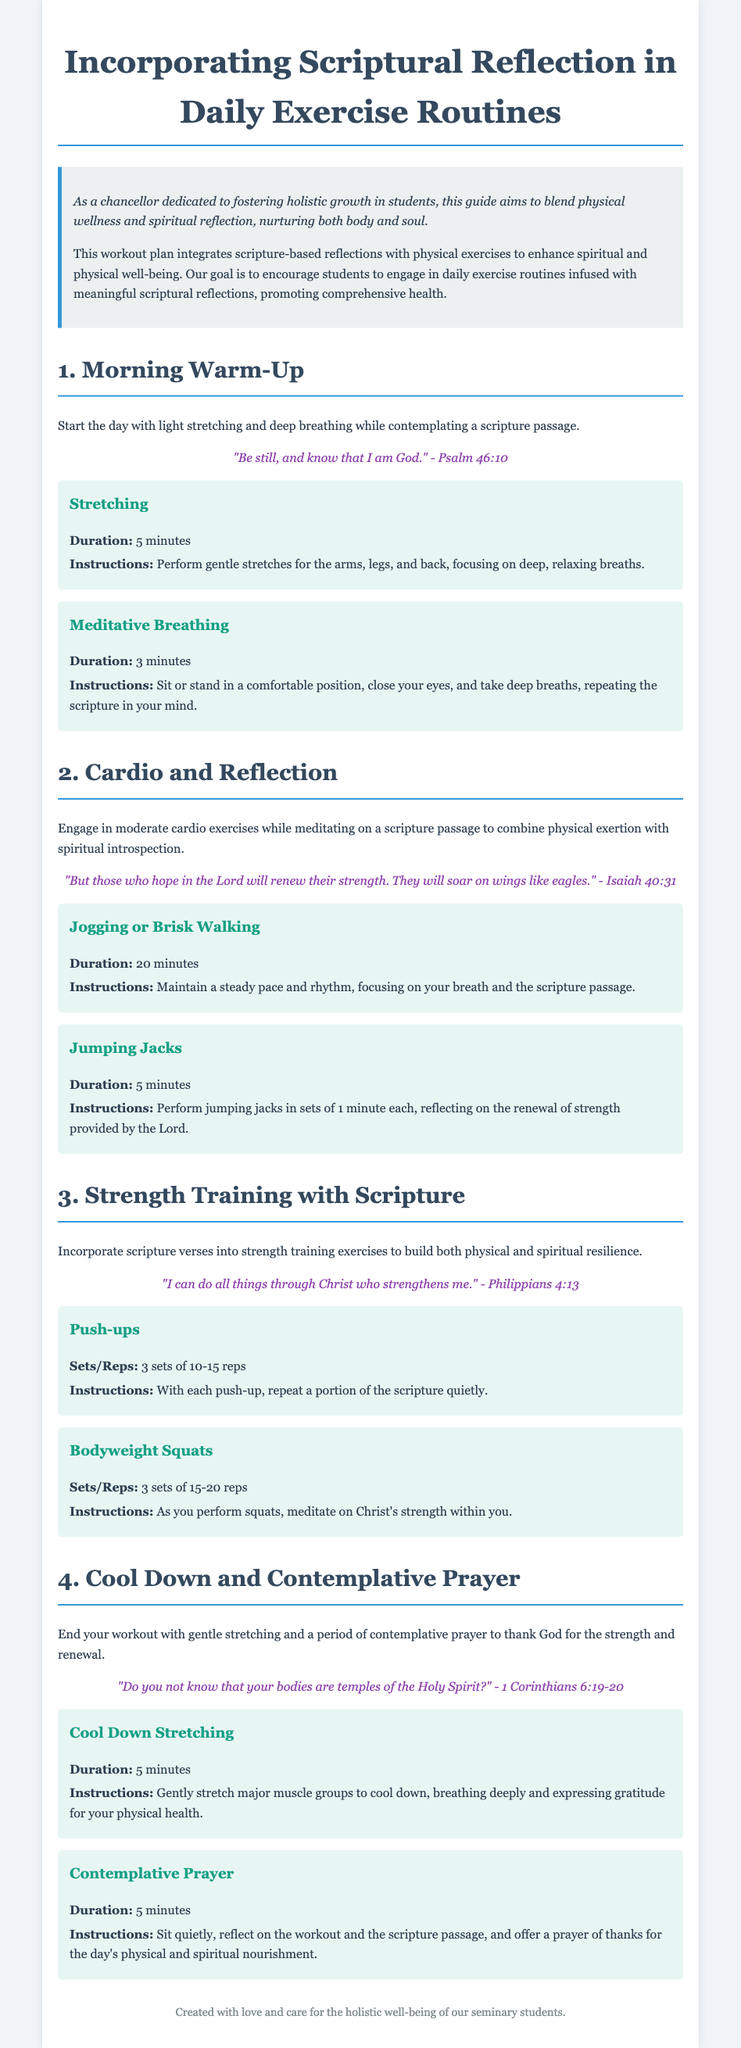what is the duration for morning stretching? The duration for morning stretching is specified in the document as 5 minutes.
Answer: 5 minutes which scripture is referenced during the cardio exercise? The scripture referenced during the cardio exercise is Isaiah 40:31.
Answer: Isaiah 40:31 how many sets of push-ups are recommended? The document recommends 3 sets of push-ups during strength training exercises.
Answer: 3 sets what is the purpose of contemplative prayer at the end of the workout? The purpose of contemplative prayer is to reflect on the workout and express gratitude for physical and spiritual nourishment.
Answer: gratitude what scripture emphasizes the importance of the body in this workout plan? The document references 1 Corinthians 6:19-20 to emphasize the importance of the body.
Answer: 1 Corinthians 6:19-20 how long should the meditative breathing last? The duration for meditative breathing is specified as 3 minutes.
Answer: 3 minutes which exercise is suggested to build physical resilience while reflecting on a scripture? The exercise suggested to build physical resilience is bodyweight squats.
Answer: bodyweight squats what is the main goal of this workout plan? The main goal of the workout plan is to blend physical wellness and spiritual reflection.
Answer: blend physical wellness and spiritual reflection 